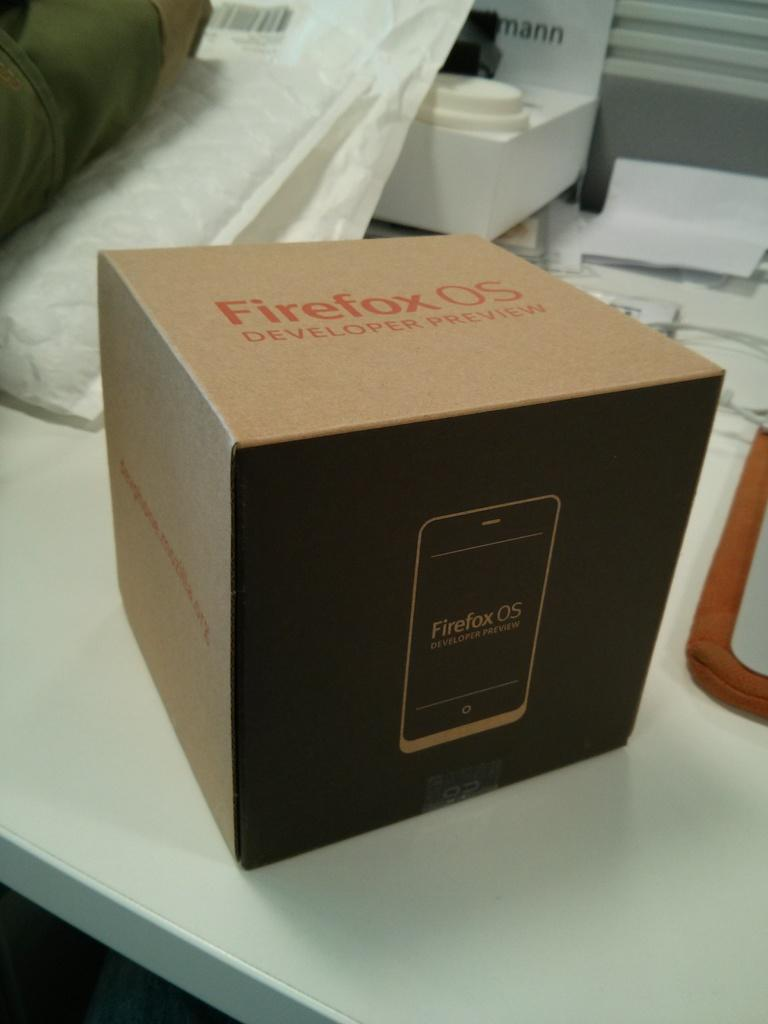<image>
Give a short and clear explanation of the subsequent image. The outside of a brown and black box advertises the Firefox OS developer preview. 